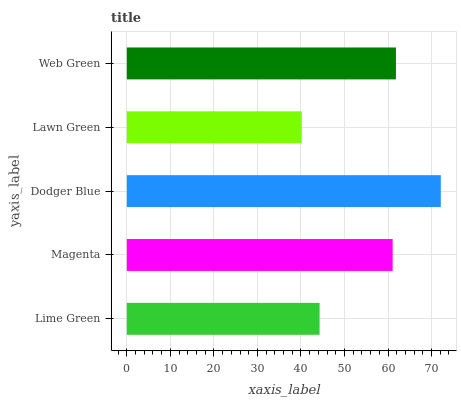Is Lawn Green the minimum?
Answer yes or no. Yes. Is Dodger Blue the maximum?
Answer yes or no. Yes. Is Magenta the minimum?
Answer yes or no. No. Is Magenta the maximum?
Answer yes or no. No. Is Magenta greater than Lime Green?
Answer yes or no. Yes. Is Lime Green less than Magenta?
Answer yes or no. Yes. Is Lime Green greater than Magenta?
Answer yes or no. No. Is Magenta less than Lime Green?
Answer yes or no. No. Is Magenta the high median?
Answer yes or no. Yes. Is Magenta the low median?
Answer yes or no. Yes. Is Web Green the high median?
Answer yes or no. No. Is Lime Green the low median?
Answer yes or no. No. 